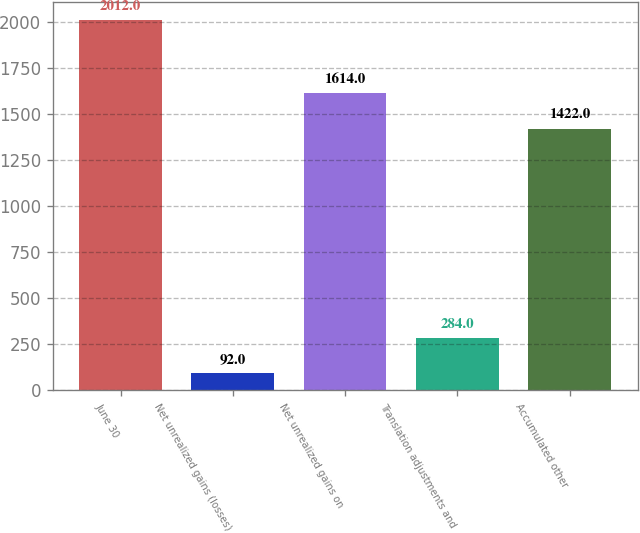<chart> <loc_0><loc_0><loc_500><loc_500><bar_chart><fcel>June 30<fcel>Net unrealized gains (losses)<fcel>Net unrealized gains on<fcel>Translation adjustments and<fcel>Accumulated other<nl><fcel>2012<fcel>92<fcel>1614<fcel>284<fcel>1422<nl></chart> 